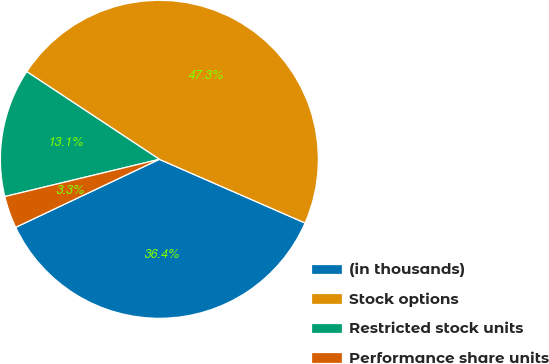Convert chart. <chart><loc_0><loc_0><loc_500><loc_500><pie_chart><fcel>(in thousands)<fcel>Stock options<fcel>Restricted stock units<fcel>Performance share units<nl><fcel>36.4%<fcel>47.26%<fcel>13.06%<fcel>3.27%<nl></chart> 